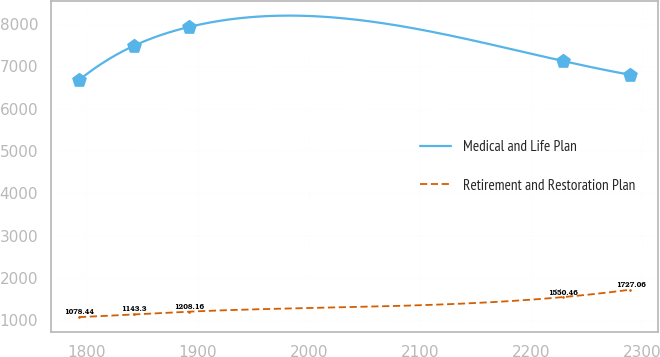<chart> <loc_0><loc_0><loc_500><loc_500><line_chart><ecel><fcel>Medical and Life Plan<fcel>Retirement and Restoration Plan<nl><fcel>1793.16<fcel>6672.69<fcel>1078.44<nl><fcel>1842.77<fcel>7486.25<fcel>1143.3<nl><fcel>1892.38<fcel>7929.8<fcel>1208.16<nl><fcel>2228.14<fcel>7127.81<fcel>1550.46<nl><fcel>2289.29<fcel>6798.4<fcel>1727.06<nl></chart> 